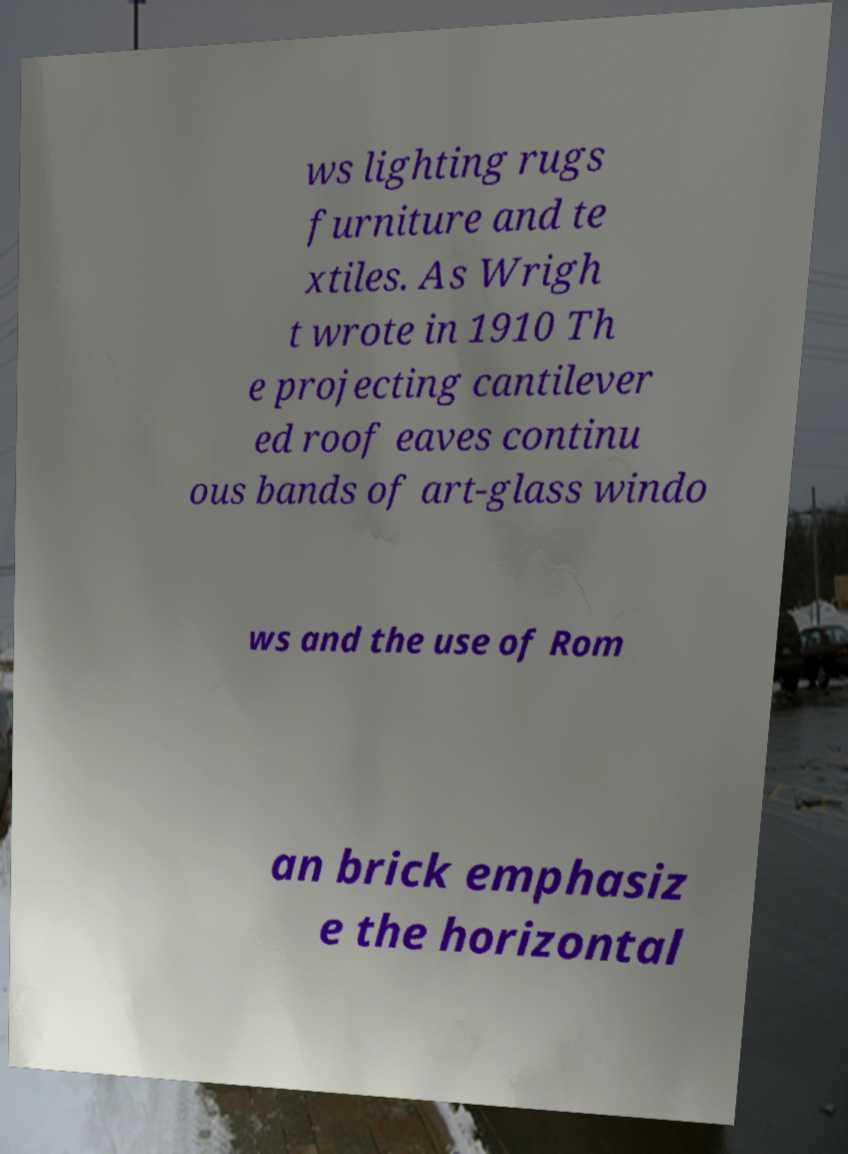There's text embedded in this image that I need extracted. Can you transcribe it verbatim? ws lighting rugs furniture and te xtiles. As Wrigh t wrote in 1910 Th e projecting cantilever ed roof eaves continu ous bands of art-glass windo ws and the use of Rom an brick emphasiz e the horizontal 